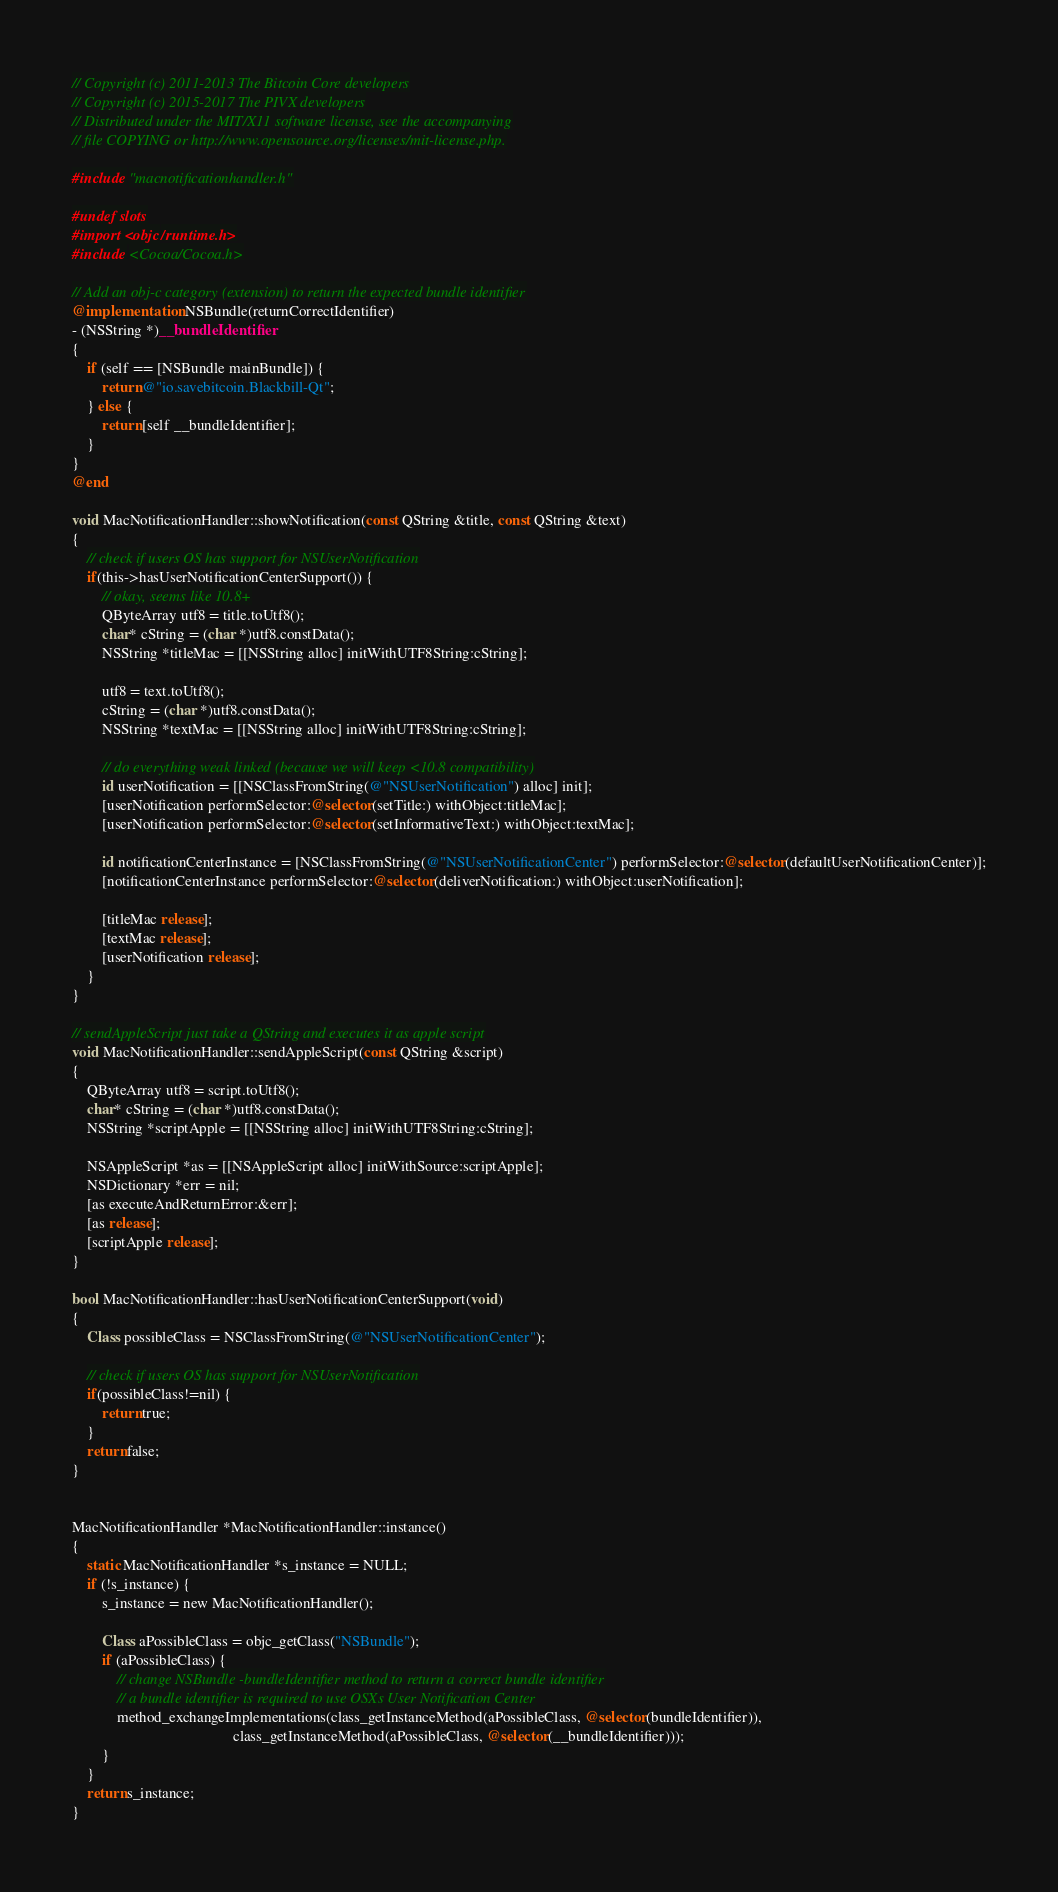Convert code to text. <code><loc_0><loc_0><loc_500><loc_500><_ObjectiveC_>// Copyright (c) 2011-2013 The Bitcoin Core developers
// Copyright (c) 2015-2017 The PIVX developers
// Distributed under the MIT/X11 software license, see the accompanying
// file COPYING or http://www.opensource.org/licenses/mit-license.php.

#include "macnotificationhandler.h"

#undef slots
#import <objc/runtime.h>
#include <Cocoa/Cocoa.h>

// Add an obj-c category (extension) to return the expected bundle identifier
@implementation NSBundle(returnCorrectIdentifier)
- (NSString *)__bundleIdentifier
{
    if (self == [NSBundle mainBundle]) {
        return @"io.savebitcoin.Blackbill-Qt";
    } else {
        return [self __bundleIdentifier];
    }
}
@end

void MacNotificationHandler::showNotification(const QString &title, const QString &text)
{
    // check if users OS has support for NSUserNotification
    if(this->hasUserNotificationCenterSupport()) {
        // okay, seems like 10.8+
        QByteArray utf8 = title.toUtf8();
        char* cString = (char *)utf8.constData();
        NSString *titleMac = [[NSString alloc] initWithUTF8String:cString];

        utf8 = text.toUtf8();
        cString = (char *)utf8.constData();
        NSString *textMac = [[NSString alloc] initWithUTF8String:cString];

        // do everything weak linked (because we will keep <10.8 compatibility)
        id userNotification = [[NSClassFromString(@"NSUserNotification") alloc] init];
        [userNotification performSelector:@selector(setTitle:) withObject:titleMac];
        [userNotification performSelector:@selector(setInformativeText:) withObject:textMac];

        id notificationCenterInstance = [NSClassFromString(@"NSUserNotificationCenter") performSelector:@selector(defaultUserNotificationCenter)];
        [notificationCenterInstance performSelector:@selector(deliverNotification:) withObject:userNotification];

        [titleMac release];
        [textMac release];
        [userNotification release];
    }
}

// sendAppleScript just take a QString and executes it as apple script
void MacNotificationHandler::sendAppleScript(const QString &script)
{
    QByteArray utf8 = script.toUtf8();
    char* cString = (char *)utf8.constData();
    NSString *scriptApple = [[NSString alloc] initWithUTF8String:cString];

    NSAppleScript *as = [[NSAppleScript alloc] initWithSource:scriptApple];
    NSDictionary *err = nil;
    [as executeAndReturnError:&err];
    [as release];
    [scriptApple release];
}

bool MacNotificationHandler::hasUserNotificationCenterSupport(void)
{
    Class possibleClass = NSClassFromString(@"NSUserNotificationCenter");

    // check if users OS has support for NSUserNotification
    if(possibleClass!=nil) {
        return true;
    }
    return false;
}


MacNotificationHandler *MacNotificationHandler::instance()
{
    static MacNotificationHandler *s_instance = NULL;
    if (!s_instance) {
        s_instance = new MacNotificationHandler();
        
        Class aPossibleClass = objc_getClass("NSBundle");
        if (aPossibleClass) {
            // change NSBundle -bundleIdentifier method to return a correct bundle identifier
            // a bundle identifier is required to use OSXs User Notification Center
            method_exchangeImplementations(class_getInstanceMethod(aPossibleClass, @selector(bundleIdentifier)),
                                           class_getInstanceMethod(aPossibleClass, @selector(__bundleIdentifier)));
        }
    }
    return s_instance;
}
</code> 